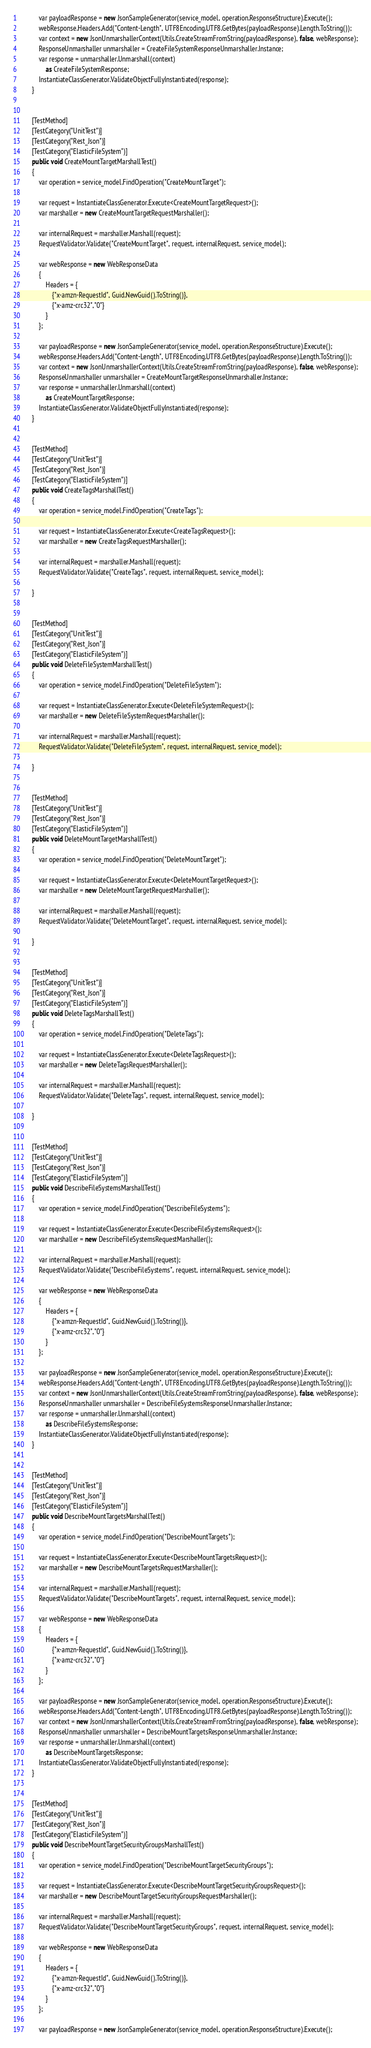<code> <loc_0><loc_0><loc_500><loc_500><_C#_>
            var payloadResponse = new JsonSampleGenerator(service_model, operation.ResponseStructure).Execute();
            webResponse.Headers.Add("Content-Length", UTF8Encoding.UTF8.GetBytes(payloadResponse).Length.ToString());
            var context = new JsonUnmarshallerContext(Utils.CreateStreamFromString(payloadResponse), false, webResponse);
            ResponseUnmarshaller unmarshaller = CreateFileSystemResponseUnmarshaller.Instance;
            var response = unmarshaller.Unmarshall(context)
                as CreateFileSystemResponse;   
            InstantiateClassGenerator.ValidateObjectFullyInstantiated(response);               
        }

        
        [TestMethod]
        [TestCategory("UnitTest")]
        [TestCategory("Rest_Json")]
        [TestCategory("ElasticFileSystem")]
        public void CreateMountTargetMarshallTest()
        {
            var operation = service_model.FindOperation("CreateMountTarget");

            var request = InstantiateClassGenerator.Execute<CreateMountTargetRequest>();
            var marshaller = new CreateMountTargetRequestMarshaller();

            var internalRequest = marshaller.Marshall(request);
            RequestValidator.Validate("CreateMountTarget", request, internalRequest, service_model);            

            var webResponse = new WebResponseData
            {
                Headers = {
                    {"x-amzn-RequestId", Guid.NewGuid().ToString()},
                    {"x-amz-crc32","0"}
                }
            };

            var payloadResponse = new JsonSampleGenerator(service_model, operation.ResponseStructure).Execute();
            webResponse.Headers.Add("Content-Length", UTF8Encoding.UTF8.GetBytes(payloadResponse).Length.ToString());
            var context = new JsonUnmarshallerContext(Utils.CreateStreamFromString(payloadResponse), false, webResponse);
            ResponseUnmarshaller unmarshaller = CreateMountTargetResponseUnmarshaller.Instance;
            var response = unmarshaller.Unmarshall(context)
                as CreateMountTargetResponse;   
            InstantiateClassGenerator.ValidateObjectFullyInstantiated(response);               
        }

        
        [TestMethod]
        [TestCategory("UnitTest")]
        [TestCategory("Rest_Json")]
        [TestCategory("ElasticFileSystem")]
        public void CreateTagsMarshallTest()
        {
            var operation = service_model.FindOperation("CreateTags");

            var request = InstantiateClassGenerator.Execute<CreateTagsRequest>();
            var marshaller = new CreateTagsRequestMarshaller();

            var internalRequest = marshaller.Marshall(request);
            RequestValidator.Validate("CreateTags", request, internalRequest, service_model);            

        }

        
        [TestMethod]
        [TestCategory("UnitTest")]
        [TestCategory("Rest_Json")]
        [TestCategory("ElasticFileSystem")]
        public void DeleteFileSystemMarshallTest()
        {
            var operation = service_model.FindOperation("DeleteFileSystem");

            var request = InstantiateClassGenerator.Execute<DeleteFileSystemRequest>();
            var marshaller = new DeleteFileSystemRequestMarshaller();

            var internalRequest = marshaller.Marshall(request);
            RequestValidator.Validate("DeleteFileSystem", request, internalRequest, service_model);            

        }

        
        [TestMethod]
        [TestCategory("UnitTest")]
        [TestCategory("Rest_Json")]
        [TestCategory("ElasticFileSystem")]
        public void DeleteMountTargetMarshallTest()
        {
            var operation = service_model.FindOperation("DeleteMountTarget");

            var request = InstantiateClassGenerator.Execute<DeleteMountTargetRequest>();
            var marshaller = new DeleteMountTargetRequestMarshaller();

            var internalRequest = marshaller.Marshall(request);
            RequestValidator.Validate("DeleteMountTarget", request, internalRequest, service_model);            

        }

        
        [TestMethod]
        [TestCategory("UnitTest")]
        [TestCategory("Rest_Json")]
        [TestCategory("ElasticFileSystem")]
        public void DeleteTagsMarshallTest()
        {
            var operation = service_model.FindOperation("DeleteTags");

            var request = InstantiateClassGenerator.Execute<DeleteTagsRequest>();
            var marshaller = new DeleteTagsRequestMarshaller();

            var internalRequest = marshaller.Marshall(request);
            RequestValidator.Validate("DeleteTags", request, internalRequest, service_model);            

        }

        
        [TestMethod]
        [TestCategory("UnitTest")]
        [TestCategory("Rest_Json")]
        [TestCategory("ElasticFileSystem")]
        public void DescribeFileSystemsMarshallTest()
        {
            var operation = service_model.FindOperation("DescribeFileSystems");

            var request = InstantiateClassGenerator.Execute<DescribeFileSystemsRequest>();
            var marshaller = new DescribeFileSystemsRequestMarshaller();

            var internalRequest = marshaller.Marshall(request);
            RequestValidator.Validate("DescribeFileSystems", request, internalRequest, service_model);            

            var webResponse = new WebResponseData
            {
                Headers = {
                    {"x-amzn-RequestId", Guid.NewGuid().ToString()},
                    {"x-amz-crc32","0"}
                }
            };

            var payloadResponse = new JsonSampleGenerator(service_model, operation.ResponseStructure).Execute();
            webResponse.Headers.Add("Content-Length", UTF8Encoding.UTF8.GetBytes(payloadResponse).Length.ToString());
            var context = new JsonUnmarshallerContext(Utils.CreateStreamFromString(payloadResponse), false, webResponse);
            ResponseUnmarshaller unmarshaller = DescribeFileSystemsResponseUnmarshaller.Instance;
            var response = unmarshaller.Unmarshall(context)
                as DescribeFileSystemsResponse;   
            InstantiateClassGenerator.ValidateObjectFullyInstantiated(response);               
        }

        
        [TestMethod]
        [TestCategory("UnitTest")]
        [TestCategory("Rest_Json")]
        [TestCategory("ElasticFileSystem")]
        public void DescribeMountTargetsMarshallTest()
        {
            var operation = service_model.FindOperation("DescribeMountTargets");

            var request = InstantiateClassGenerator.Execute<DescribeMountTargetsRequest>();
            var marshaller = new DescribeMountTargetsRequestMarshaller();

            var internalRequest = marshaller.Marshall(request);
            RequestValidator.Validate("DescribeMountTargets", request, internalRequest, service_model);            

            var webResponse = new WebResponseData
            {
                Headers = {
                    {"x-amzn-RequestId", Guid.NewGuid().ToString()},
                    {"x-amz-crc32","0"}
                }
            };

            var payloadResponse = new JsonSampleGenerator(service_model, operation.ResponseStructure).Execute();
            webResponse.Headers.Add("Content-Length", UTF8Encoding.UTF8.GetBytes(payloadResponse).Length.ToString());
            var context = new JsonUnmarshallerContext(Utils.CreateStreamFromString(payloadResponse), false, webResponse);
            ResponseUnmarshaller unmarshaller = DescribeMountTargetsResponseUnmarshaller.Instance;
            var response = unmarshaller.Unmarshall(context)
                as DescribeMountTargetsResponse;   
            InstantiateClassGenerator.ValidateObjectFullyInstantiated(response);               
        }

        
        [TestMethod]
        [TestCategory("UnitTest")]
        [TestCategory("Rest_Json")]
        [TestCategory("ElasticFileSystem")]
        public void DescribeMountTargetSecurityGroupsMarshallTest()
        {
            var operation = service_model.FindOperation("DescribeMountTargetSecurityGroups");

            var request = InstantiateClassGenerator.Execute<DescribeMountTargetSecurityGroupsRequest>();
            var marshaller = new DescribeMountTargetSecurityGroupsRequestMarshaller();

            var internalRequest = marshaller.Marshall(request);
            RequestValidator.Validate("DescribeMountTargetSecurityGroups", request, internalRequest, service_model);            

            var webResponse = new WebResponseData
            {
                Headers = {
                    {"x-amzn-RequestId", Guid.NewGuid().ToString()},
                    {"x-amz-crc32","0"}
                }
            };

            var payloadResponse = new JsonSampleGenerator(service_model, operation.ResponseStructure).Execute();</code> 